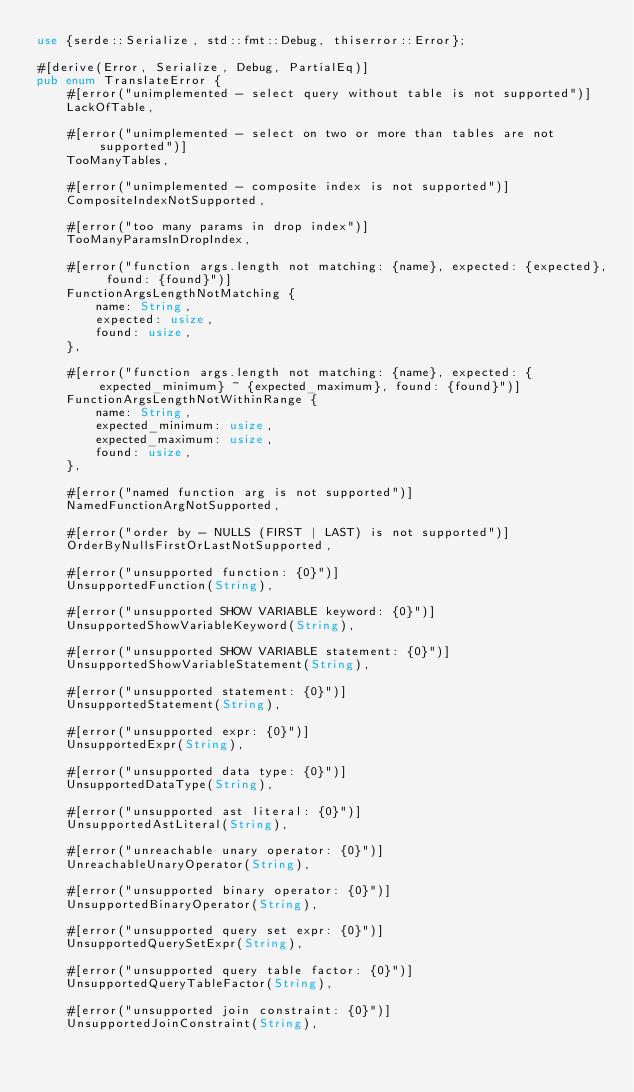<code> <loc_0><loc_0><loc_500><loc_500><_Rust_>use {serde::Serialize, std::fmt::Debug, thiserror::Error};

#[derive(Error, Serialize, Debug, PartialEq)]
pub enum TranslateError {
    #[error("unimplemented - select query without table is not supported")]
    LackOfTable,

    #[error("unimplemented - select on two or more than tables are not supported")]
    TooManyTables,

    #[error("unimplemented - composite index is not supported")]
    CompositeIndexNotSupported,

    #[error("too many params in drop index")]
    TooManyParamsInDropIndex,

    #[error("function args.length not matching: {name}, expected: {expected}, found: {found}")]
    FunctionArgsLengthNotMatching {
        name: String,
        expected: usize,
        found: usize,
    },

    #[error("function args.length not matching: {name}, expected: {expected_minimum} ~ {expected_maximum}, found: {found}")]
    FunctionArgsLengthNotWithinRange {
        name: String,
        expected_minimum: usize,
        expected_maximum: usize,
        found: usize,
    },

    #[error("named function arg is not supported")]
    NamedFunctionArgNotSupported,

    #[error("order by - NULLS (FIRST | LAST) is not supported")]
    OrderByNullsFirstOrLastNotSupported,

    #[error("unsupported function: {0}")]
    UnsupportedFunction(String),

    #[error("unsupported SHOW VARIABLE keyword: {0}")]
    UnsupportedShowVariableKeyword(String),

    #[error("unsupported SHOW VARIABLE statement: {0}")]
    UnsupportedShowVariableStatement(String),

    #[error("unsupported statement: {0}")]
    UnsupportedStatement(String),

    #[error("unsupported expr: {0}")]
    UnsupportedExpr(String),

    #[error("unsupported data type: {0}")]
    UnsupportedDataType(String),

    #[error("unsupported ast literal: {0}")]
    UnsupportedAstLiteral(String),

    #[error("unreachable unary operator: {0}")]
    UnreachableUnaryOperator(String),

    #[error("unsupported binary operator: {0}")]
    UnsupportedBinaryOperator(String),

    #[error("unsupported query set expr: {0}")]
    UnsupportedQuerySetExpr(String),

    #[error("unsupported query table factor: {0}")]
    UnsupportedQueryTableFactor(String),

    #[error("unsupported join constraint: {0}")]
    UnsupportedJoinConstraint(String),
</code> 